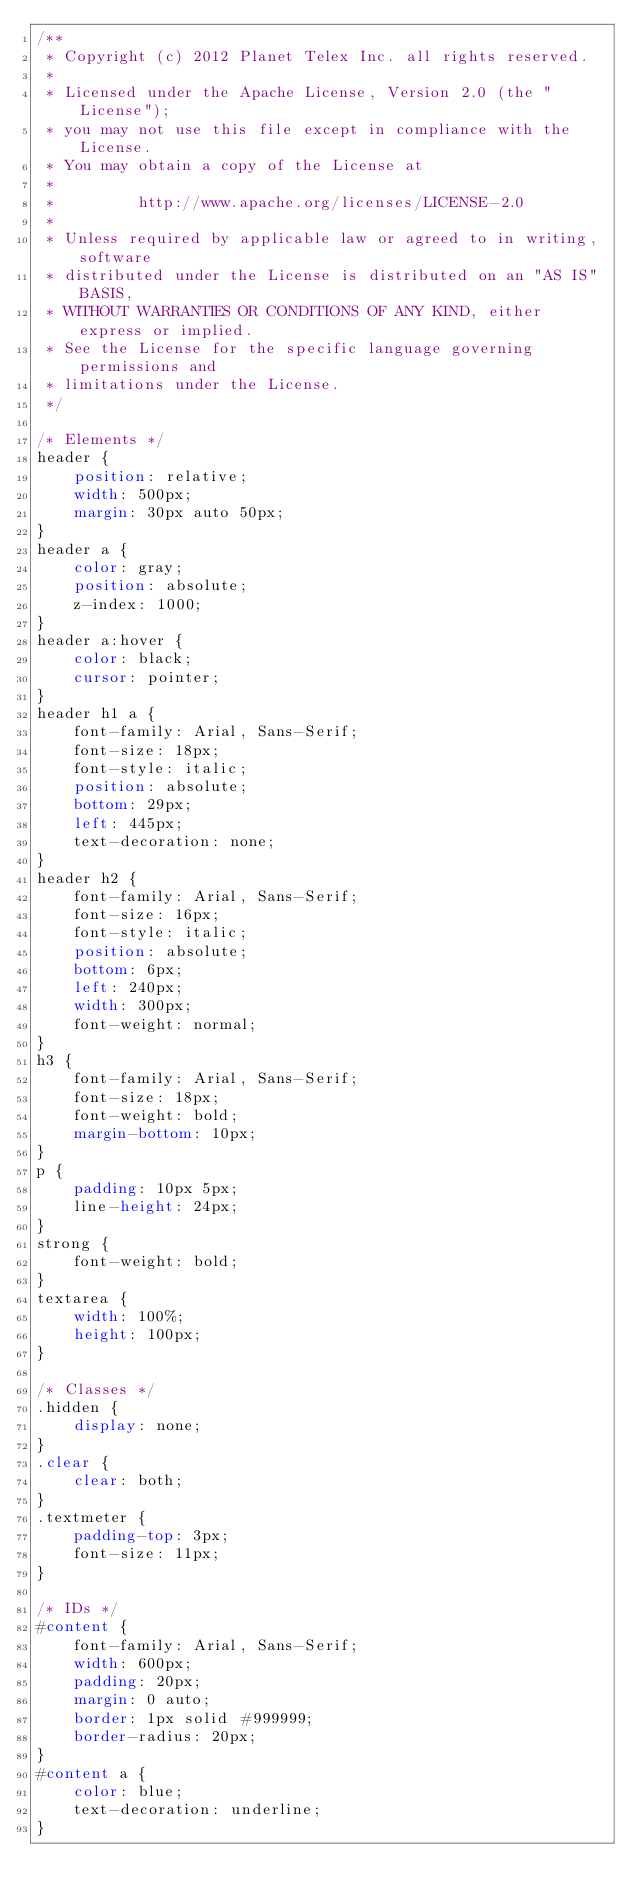Convert code to text. <code><loc_0><loc_0><loc_500><loc_500><_CSS_>/**
 * Copyright (c) 2012 Planet Telex Inc. all rights reserved.
 *
 * Licensed under the Apache License, Version 2.0 (the "License");
 * you may not use this file except in compliance with the License.
 * You may obtain a copy of the License at
 *
 *         http://www.apache.org/licenses/LICENSE-2.0
 *
 * Unless required by applicable law or agreed to in writing, software
 * distributed under the License is distributed on an "AS IS" BASIS,
 * WITHOUT WARRANTIES OR CONDITIONS OF ANY KIND, either express or implied.
 * See the License for the specific language governing permissions and
 * limitations under the License.
 */

/* Elements */
header {
    position: relative;
    width: 500px;
    margin: 30px auto 50px;
}
header a {
    color: gray;
    position: absolute;
    z-index: 1000;
}
header a:hover {
    color: black;
    cursor: pointer;
}
header h1 a {
    font-family: Arial, Sans-Serif;
    font-size: 18px;
    font-style: italic;
    position: absolute;
    bottom: 29px;
    left: 445px;
    text-decoration: none;
}
header h2 {
    font-family: Arial, Sans-Serif;
    font-size: 16px;
    font-style: italic;
    position: absolute;
    bottom: 6px;
    left: 240px;
    width: 300px;
    font-weight: normal;
}
h3 {
    font-family: Arial, Sans-Serif;
    font-size: 18px;
    font-weight: bold;
    margin-bottom: 10px;
}
p {
    padding: 10px 5px;
    line-height: 24px;
}
strong {
    font-weight: bold;
}
textarea {
    width: 100%;
    height: 100px;
}

/* Classes */
.hidden {
    display: none;
}
.clear {
    clear: both;
}
.textmeter {
    padding-top: 3px;
    font-size: 11px;
}

/* IDs */
#content {
    font-family: Arial, Sans-Serif;
    width: 600px;
    padding: 20px;
    margin: 0 auto;
    border: 1px solid #999999;
    border-radius: 20px;
}
#content a {
    color: blue;
    text-decoration: underline;
}</code> 